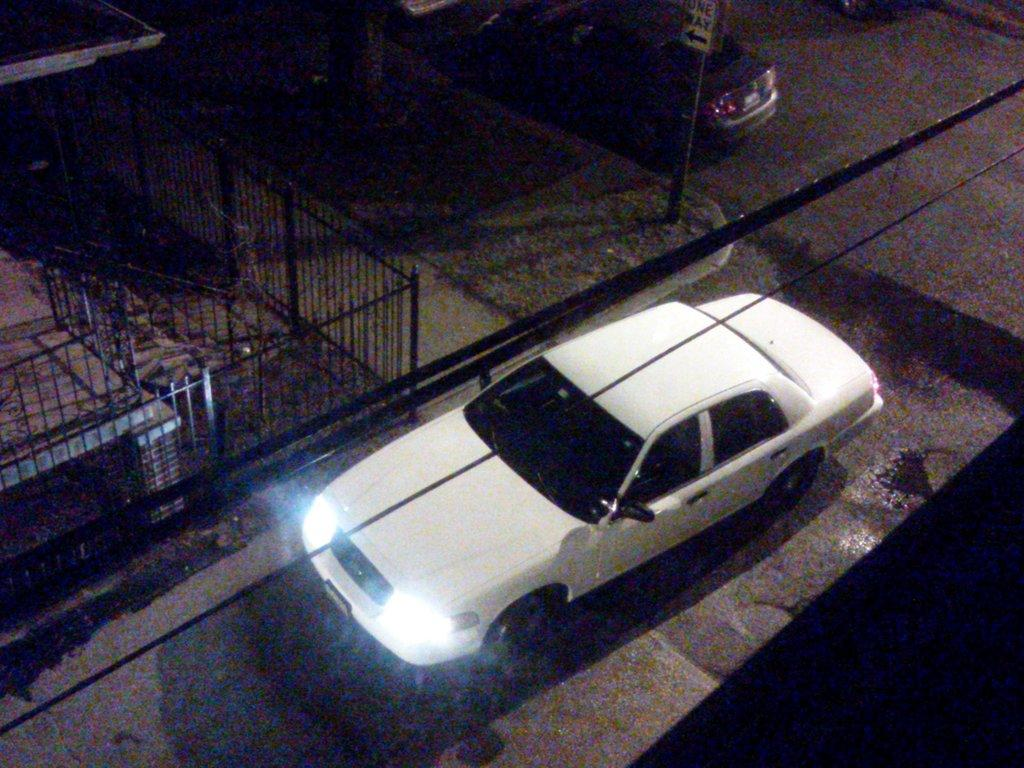How many cars are present in the image? There are two cars in the image. What is the purpose of the fencing in the image? The purpose of the fencing in the image is not specified, but it could be for safety or to mark a boundary. What is the sign board in the image used for? The purpose of the sign board in the image is not specified, but it could be for providing information or directions. What type of quilt is draped over the cars in the image? There is no quilt present in the image; it only features two cars, fencing, and a sign board. 